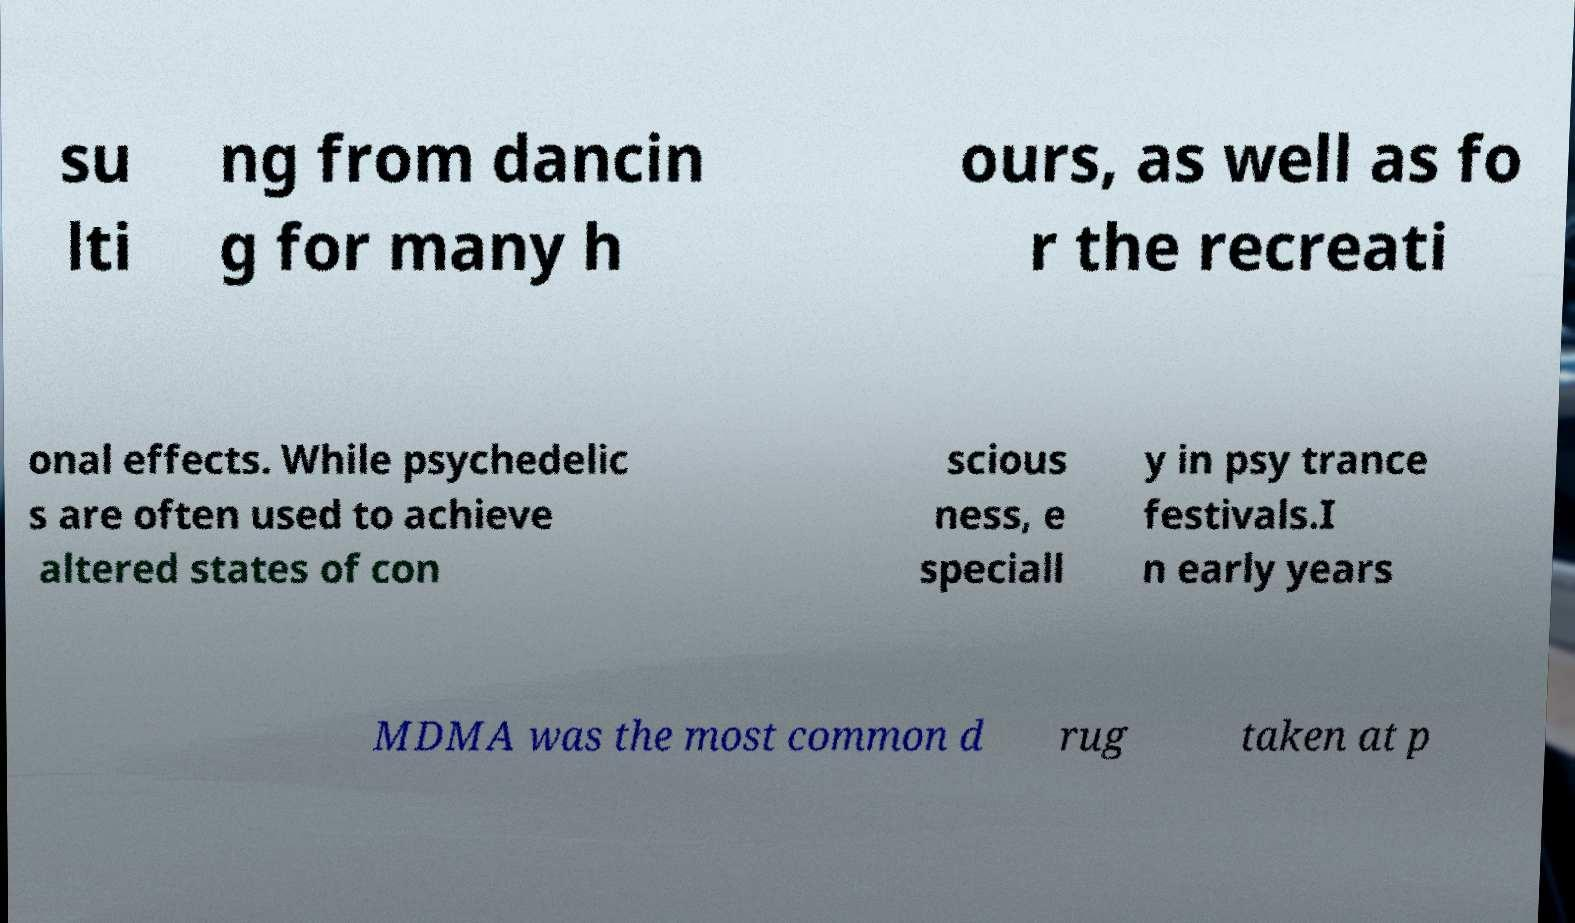For documentation purposes, I need the text within this image transcribed. Could you provide that? su lti ng from dancin g for many h ours, as well as fo r the recreati onal effects. While psychedelic s are often used to achieve altered states of con scious ness, e speciall y in psy trance festivals.I n early years MDMA was the most common d rug taken at p 